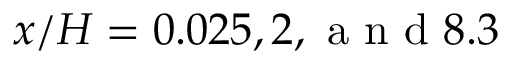<formula> <loc_0><loc_0><loc_500><loc_500>x / H = 0 . 0 2 5 , 2 , a n d 8 . 3</formula> 